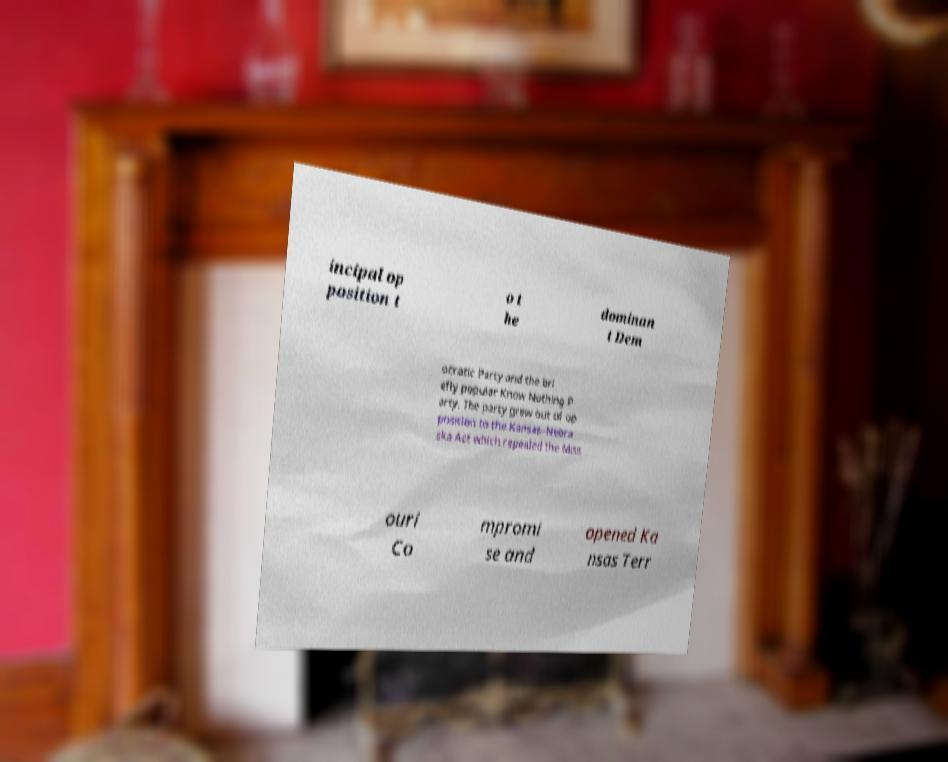Can you read and provide the text displayed in the image?This photo seems to have some interesting text. Can you extract and type it out for me? incipal op position t o t he dominan t Dem ocratic Party and the bri efly popular Know Nothing P arty. The party grew out of op position to the Kansas–Nebra ska Act which repealed the Miss ouri Co mpromi se and opened Ka nsas Terr 